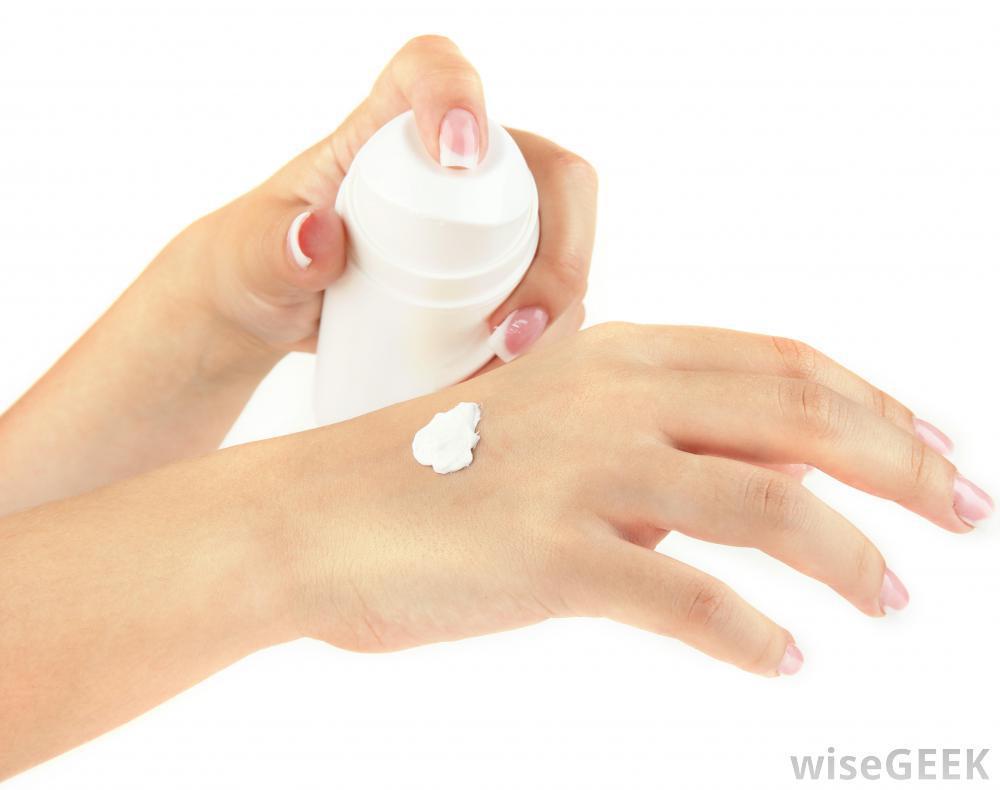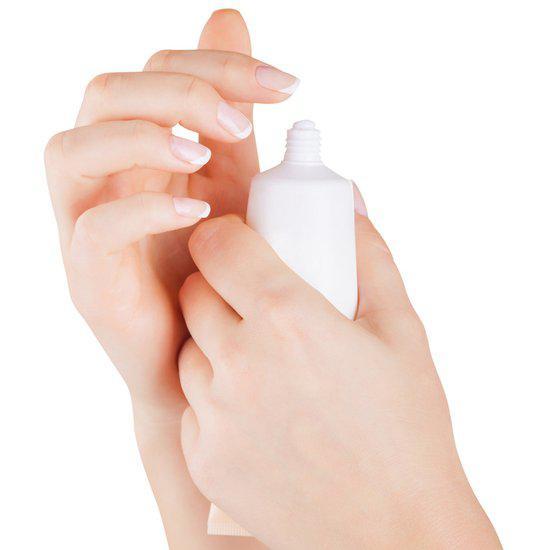The first image is the image on the left, the second image is the image on the right. Given the left and right images, does the statement "The left and right image contains the same number of closed lotion bottles." hold true? Answer yes or no. No. The first image is the image on the left, the second image is the image on the right. For the images shown, is this caption "One image shows the finger of one hand pressing the top of a white bottle to squirt lotion on another hand." true? Answer yes or no. Yes. 